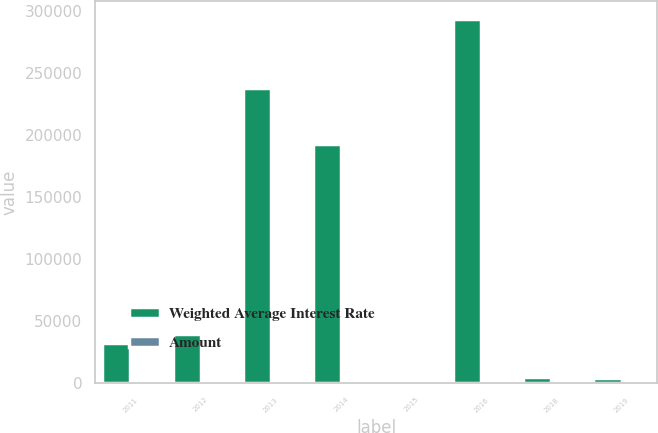Convert chart to OTSL. <chart><loc_0><loc_0><loc_500><loc_500><stacked_bar_chart><ecel><fcel>2011<fcel>2012<fcel>2013<fcel>2014<fcel>2015<fcel>2016<fcel>2018<fcel>2019<nl><fcel>Weighted Average Interest Rate<fcel>32806<fcel>40065<fcel>237700<fcel>193142<fcel>6.74<fcel>293650<fcel>5320<fcel>4096<nl><fcel>Amount<fcel>6.01<fcel>5.09<fcel>6<fcel>5.74<fcel>6.24<fcel>6.74<fcel>5.9<fcel>5.7<nl></chart> 